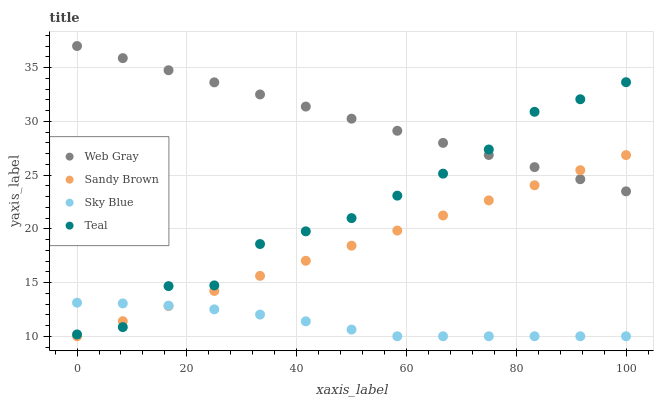Does Sky Blue have the minimum area under the curve?
Answer yes or no. Yes. Does Web Gray have the maximum area under the curve?
Answer yes or no. Yes. Does Sandy Brown have the minimum area under the curve?
Answer yes or no. No. Does Sandy Brown have the maximum area under the curve?
Answer yes or no. No. Is Sandy Brown the smoothest?
Answer yes or no. Yes. Is Teal the roughest?
Answer yes or no. Yes. Is Web Gray the smoothest?
Answer yes or no. No. Is Web Gray the roughest?
Answer yes or no. No. Does Sky Blue have the lowest value?
Answer yes or no. Yes. Does Web Gray have the lowest value?
Answer yes or no. No. Does Web Gray have the highest value?
Answer yes or no. Yes. Does Sandy Brown have the highest value?
Answer yes or no. No. Is Sky Blue less than Web Gray?
Answer yes or no. Yes. Is Web Gray greater than Sky Blue?
Answer yes or no. Yes. Does Sandy Brown intersect Web Gray?
Answer yes or no. Yes. Is Sandy Brown less than Web Gray?
Answer yes or no. No. Is Sandy Brown greater than Web Gray?
Answer yes or no. No. Does Sky Blue intersect Web Gray?
Answer yes or no. No. 